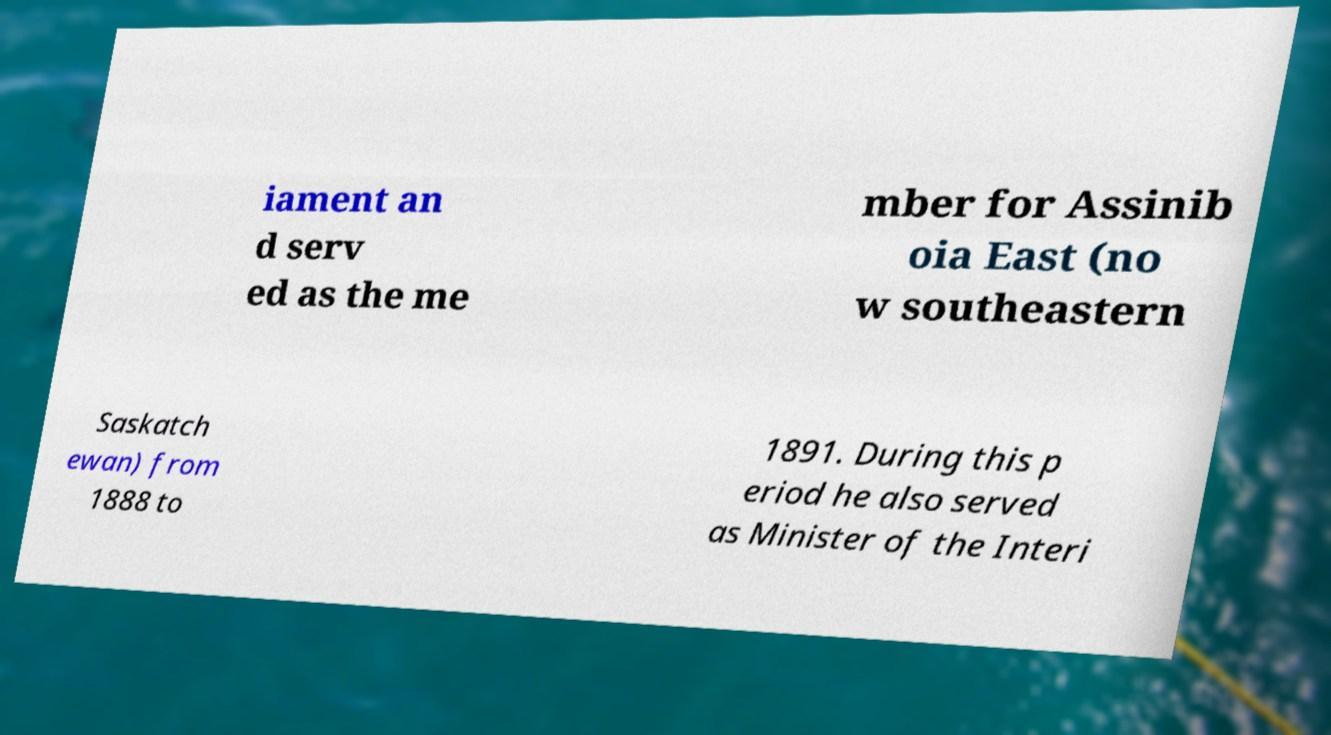I need the written content from this picture converted into text. Can you do that? iament an d serv ed as the me mber for Assinib oia East (no w southeastern Saskatch ewan) from 1888 to 1891. During this p eriod he also served as Minister of the Interi 